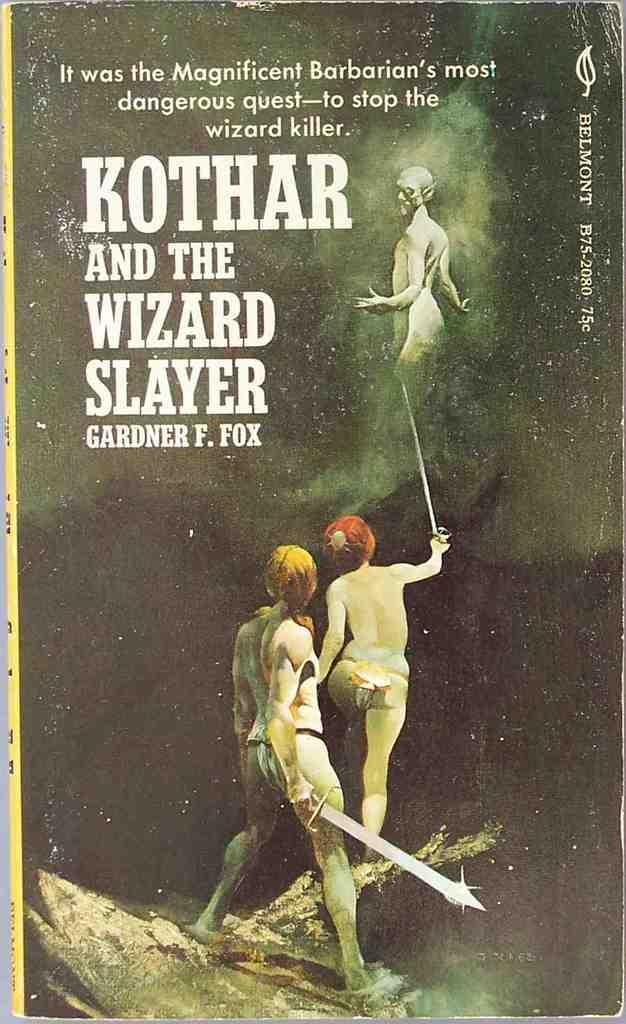Could you give a brief overview of what you see in this image? This picture is consists of a poster, on which it is written as ''Gardner f. fox.'' 